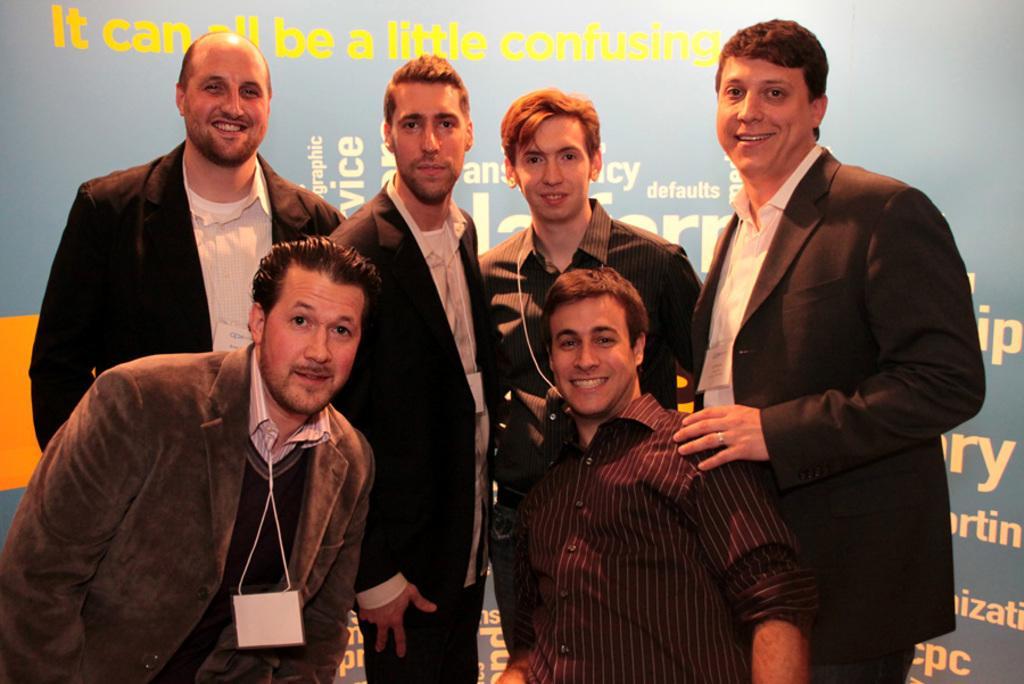Please provide a concise description of this image. In this image we can see a few people smiling, in the background, we can see a banner with some text on it. 